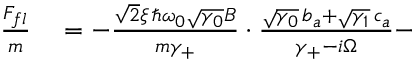<formula> <loc_0><loc_0><loc_500><loc_500>\begin{array} { r l } { \frac { F _ { f l } } { m } } & = - \frac { \sqrt { 2 } \xi \, \hslash \omega _ { 0 } \sqrt { \gamma _ { 0 } } B } { m \gamma _ { + } } \cdot \frac { \sqrt { \gamma _ { 0 } } \, b _ { a } + \sqrt { \gamma _ { 1 } } \, c _ { a } } { \gamma _ { + } - i \Omega } - } \end{array}</formula> 